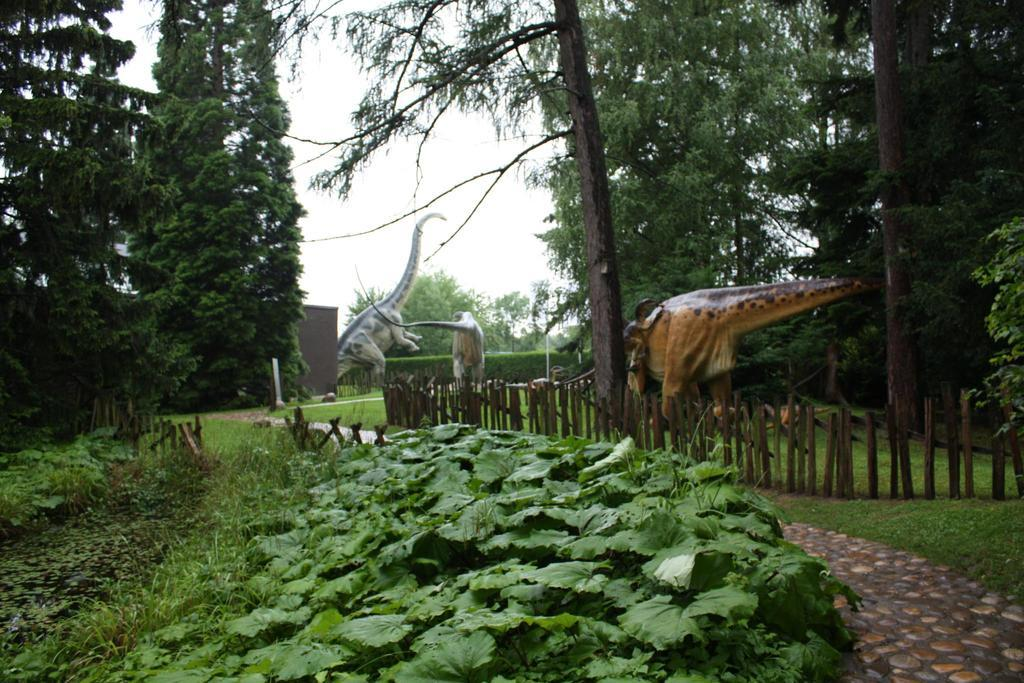What type of objects are depicted as sculptures in the image? There are sculptures of animals in the image. What type of natural elements can be seen in the image? There are trees and plants in the image. What type of barrier is present in the image? There is fencing in the image. What type of jeans are hanging on the trees in the image? There are no jeans present in the image; it only features sculptures of animals, trees, plants, and fencing. Can you see any insects crawling on the plants in the image? There is no mention of insects in the image, so we cannot determine if any are present. 